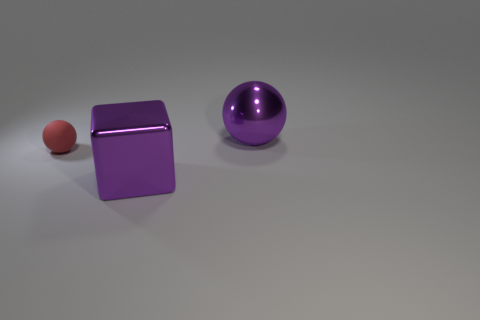Add 2 green rubber cylinders. How many objects exist? 5 Subtract all cubes. How many objects are left? 2 Subtract all big purple cubes. Subtract all purple metallic spheres. How many objects are left? 1 Add 3 small matte balls. How many small matte balls are left? 4 Add 3 balls. How many balls exist? 5 Subtract 0 gray balls. How many objects are left? 3 